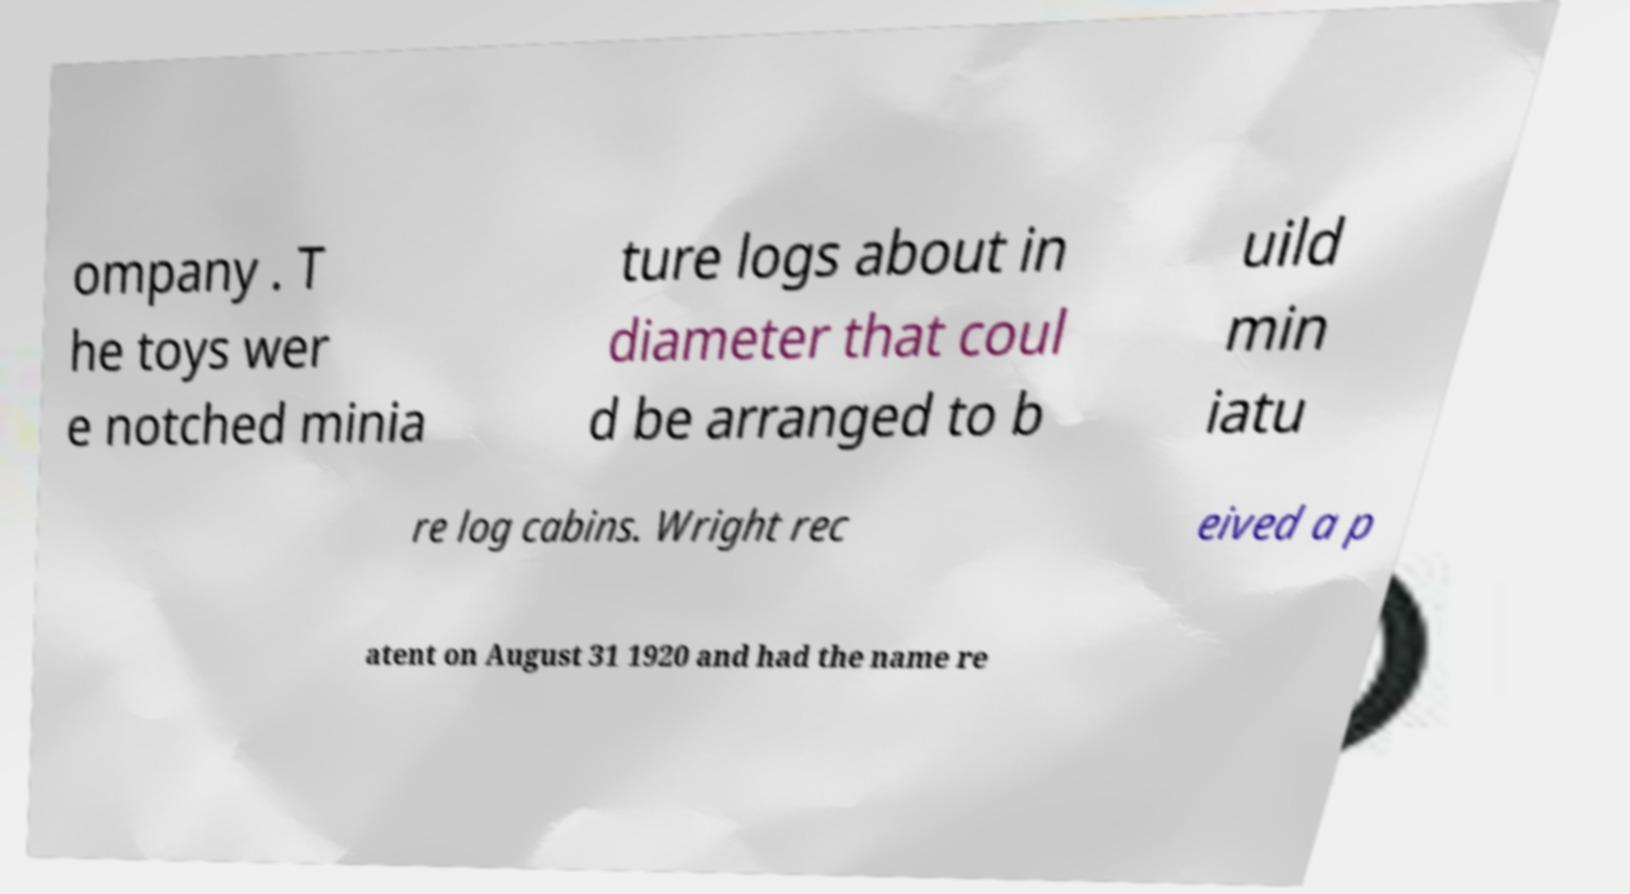Please identify and transcribe the text found in this image. ompany . T he toys wer e notched minia ture logs about in diameter that coul d be arranged to b uild min iatu re log cabins. Wright rec eived a p atent on August 31 1920 and had the name re 